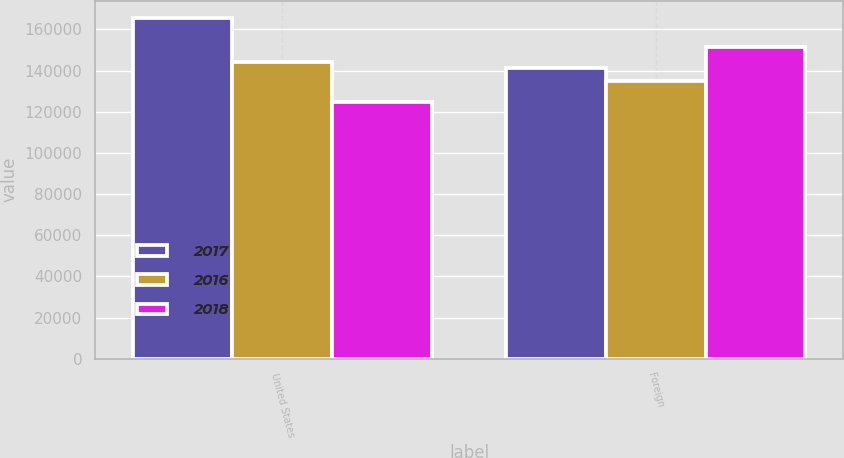Convert chart to OTSL. <chart><loc_0><loc_0><loc_500><loc_500><stacked_bar_chart><ecel><fcel>United States<fcel>Foreign<nl><fcel>2017<fcel>165719<fcel>141384<nl><fcel>2016<fcel>143924<fcel>135141<nl><fcel>2018<fcel>124500<fcel>151457<nl></chart> 